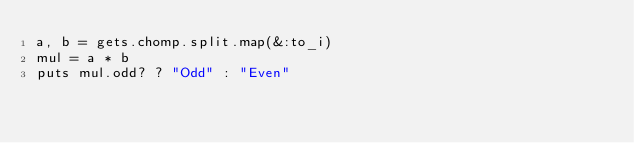Convert code to text. <code><loc_0><loc_0><loc_500><loc_500><_Ruby_>a, b = gets.chomp.split.map(&:to_i)
mul = a * b
puts mul.odd? ? "Odd" : "Even"</code> 